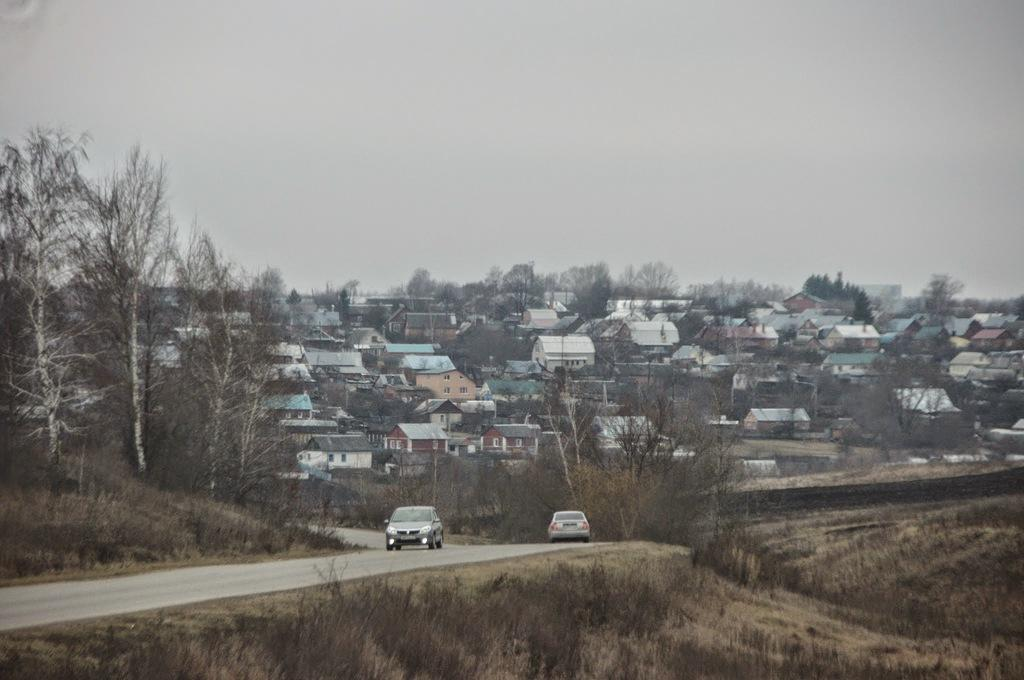What is happening in the image? There are cars on a road in the image. What can be seen in the background of the image? There are trees, houses, and the sky visible in the background of the image. How many dogs are wearing boots in the image? There are no dogs or boots present in the image. 